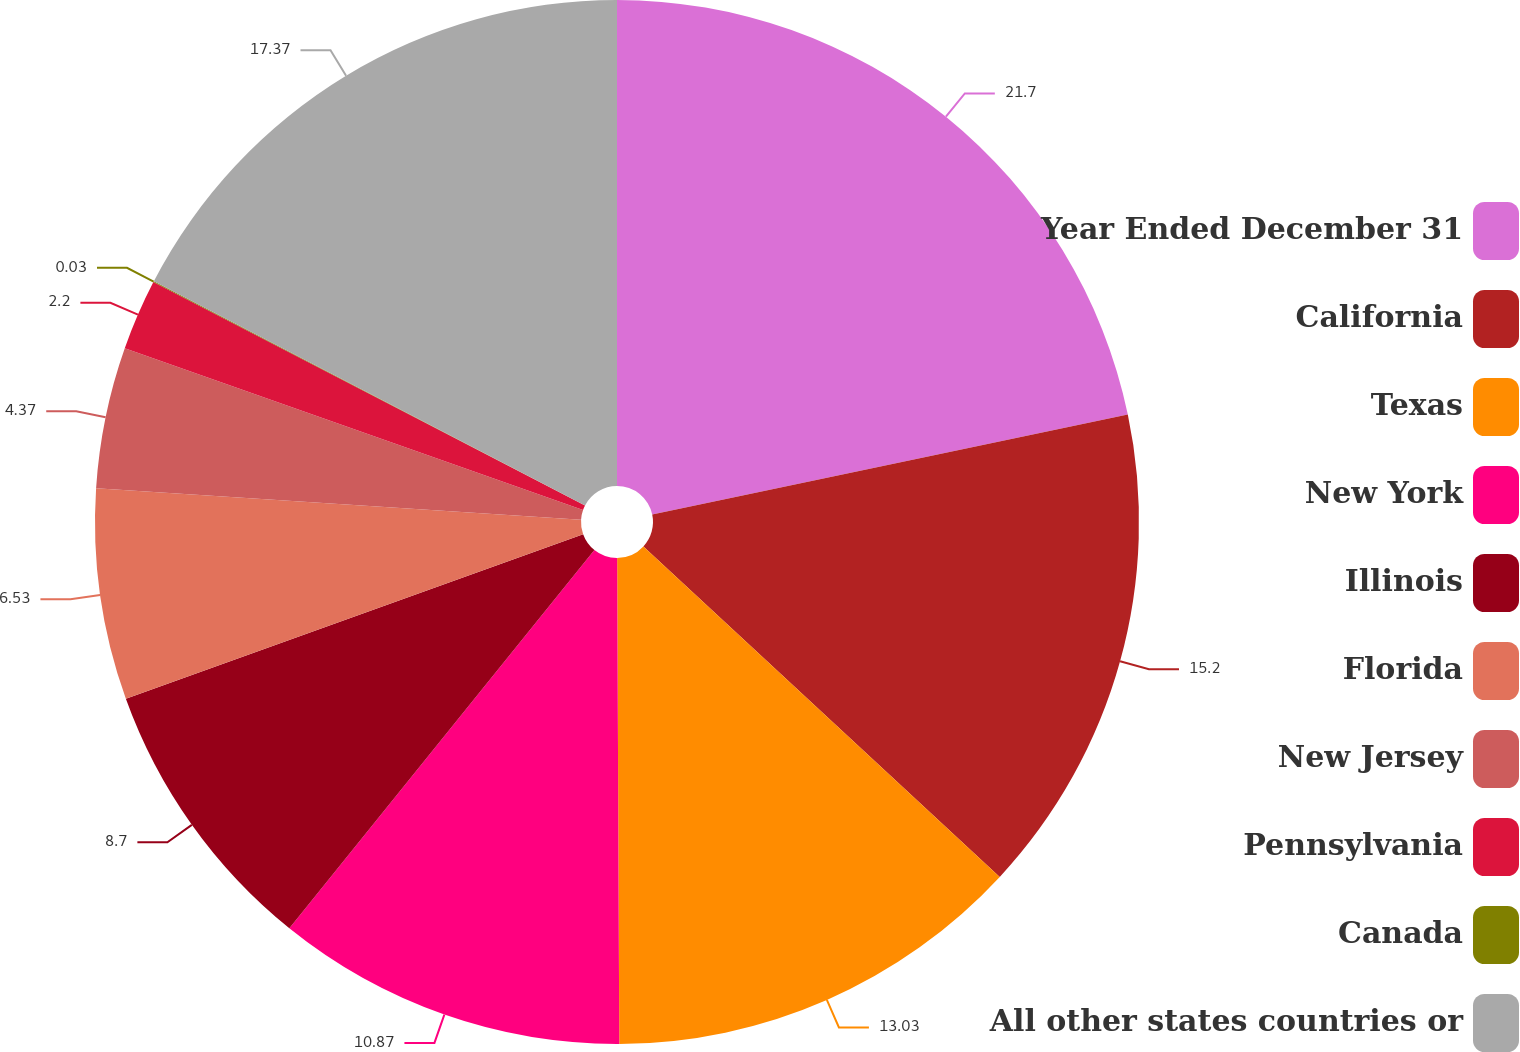Convert chart. <chart><loc_0><loc_0><loc_500><loc_500><pie_chart><fcel>Year Ended December 31<fcel>California<fcel>Texas<fcel>New York<fcel>Illinois<fcel>Florida<fcel>New Jersey<fcel>Pennsylvania<fcel>Canada<fcel>All other states countries or<nl><fcel>21.7%<fcel>15.2%<fcel>13.03%<fcel>10.87%<fcel>8.7%<fcel>6.53%<fcel>4.37%<fcel>2.2%<fcel>0.03%<fcel>17.37%<nl></chart> 